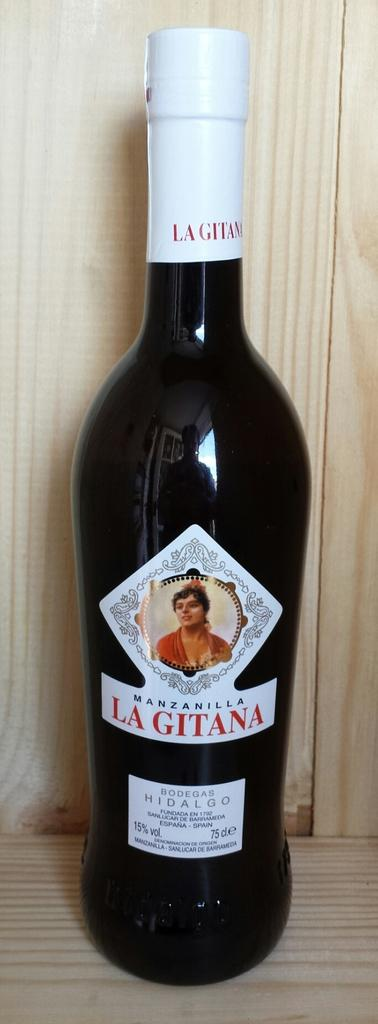Provide a one-sentence caption for the provided image. A dark colored bottle bearing the name Lagitana is sitting on a wooden shelf. 